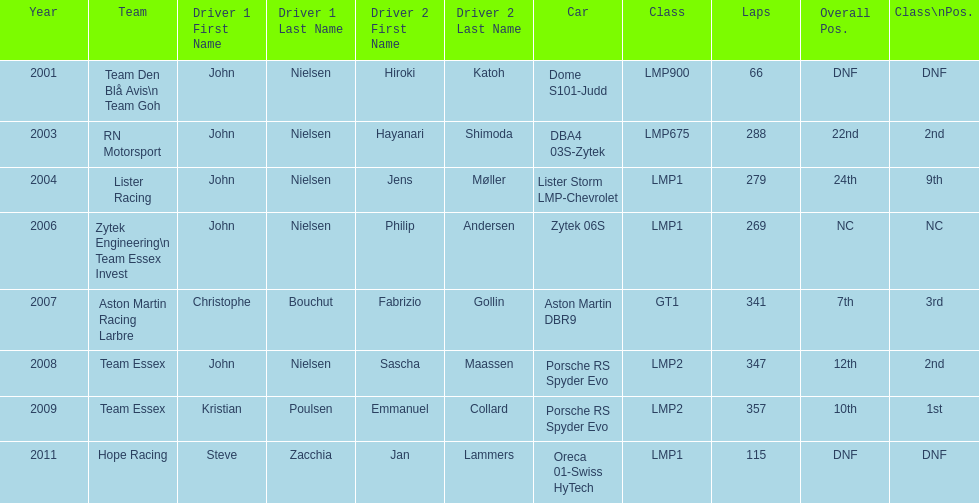What model car was the most used? Porsche RS Spyder. 